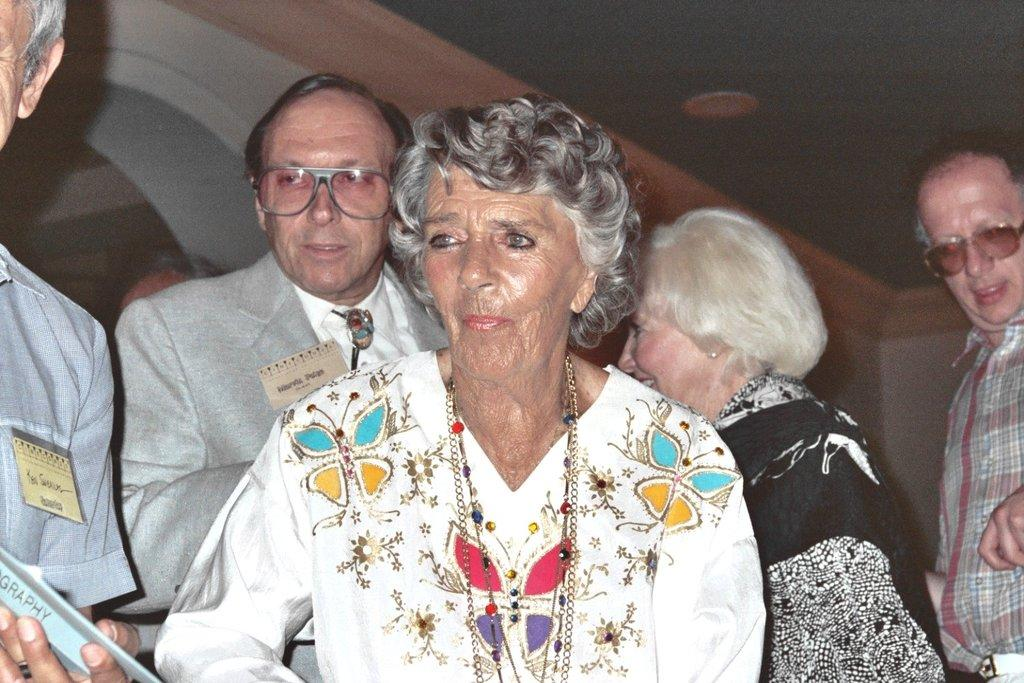How many people are in the image? There are people in the image. What is one person doing in the image? One person is holding a book. What can be seen in the background of the image? There is a wall in the background of the image. Can you see a thread being used to sew a hat in the image? There is no thread or hat being sewn in the image. 